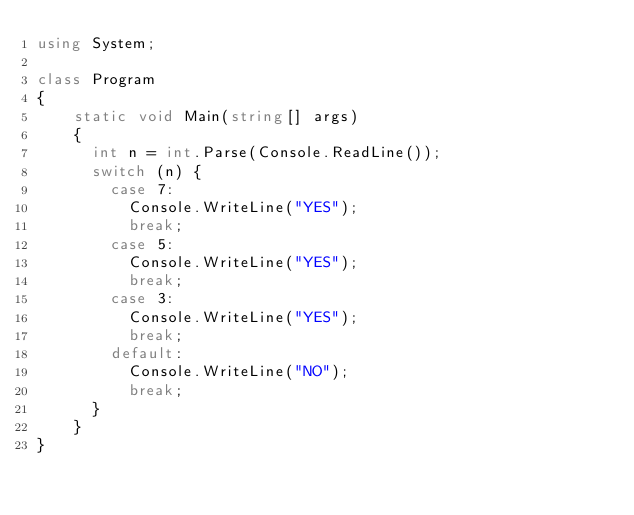Convert code to text. <code><loc_0><loc_0><loc_500><loc_500><_C#_>using System;
 
class Program
{
    static void Main(string[] args)
    {
      int n = int.Parse(Console.ReadLine());
      switch (n) {
        case 7:
          Console.WriteLine("YES");
          break;
        case 5:
          Console.WriteLine("YES");
          break;
        case 3:
          Console.WriteLine("YES");
          break;
        default:
          Console.WriteLine("NO");
          break;
      }
    }
}</code> 